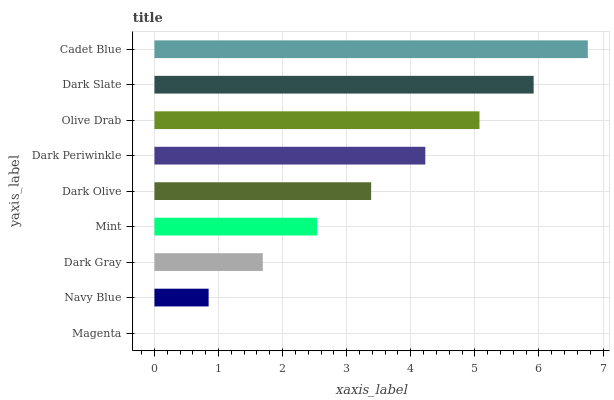Is Magenta the minimum?
Answer yes or no. Yes. Is Cadet Blue the maximum?
Answer yes or no. Yes. Is Navy Blue the minimum?
Answer yes or no. No. Is Navy Blue the maximum?
Answer yes or no. No. Is Navy Blue greater than Magenta?
Answer yes or no. Yes. Is Magenta less than Navy Blue?
Answer yes or no. Yes. Is Magenta greater than Navy Blue?
Answer yes or no. No. Is Navy Blue less than Magenta?
Answer yes or no. No. Is Dark Olive the high median?
Answer yes or no. Yes. Is Dark Olive the low median?
Answer yes or no. Yes. Is Magenta the high median?
Answer yes or no. No. Is Dark Periwinkle the low median?
Answer yes or no. No. 